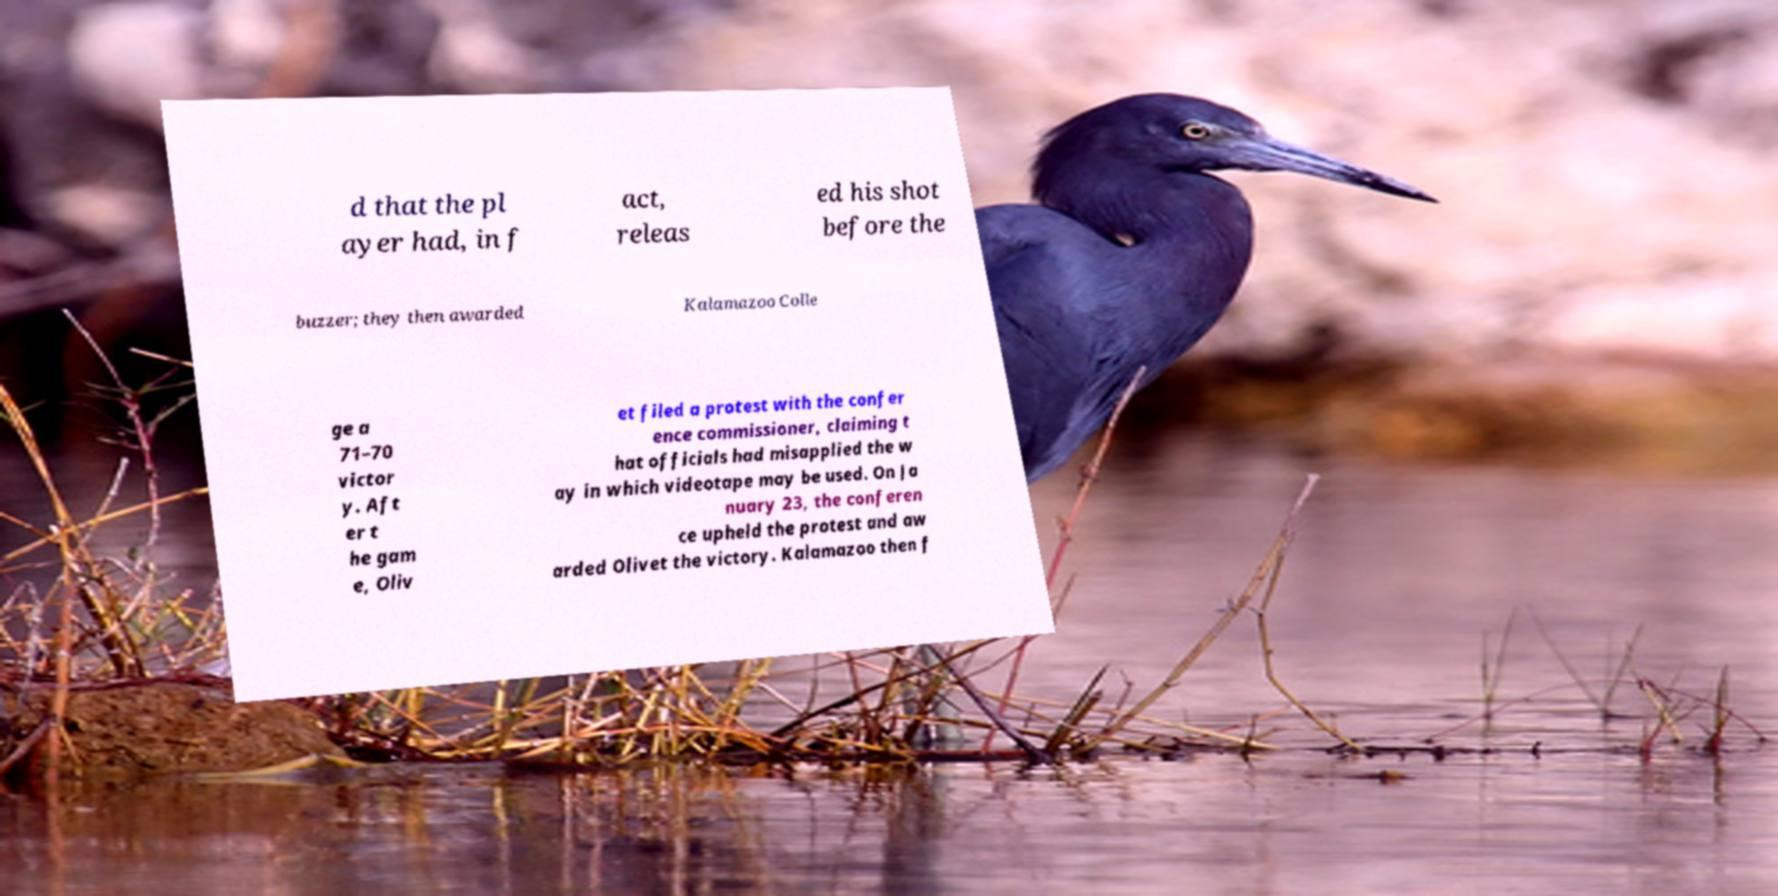Can you accurately transcribe the text from the provided image for me? d that the pl ayer had, in f act, releas ed his shot before the buzzer; they then awarded Kalamazoo Colle ge a 71–70 victor y. Aft er t he gam e, Oliv et filed a protest with the confer ence commissioner, claiming t hat officials had misapplied the w ay in which videotape may be used. On Ja nuary 23, the conferen ce upheld the protest and aw arded Olivet the victory. Kalamazoo then f 